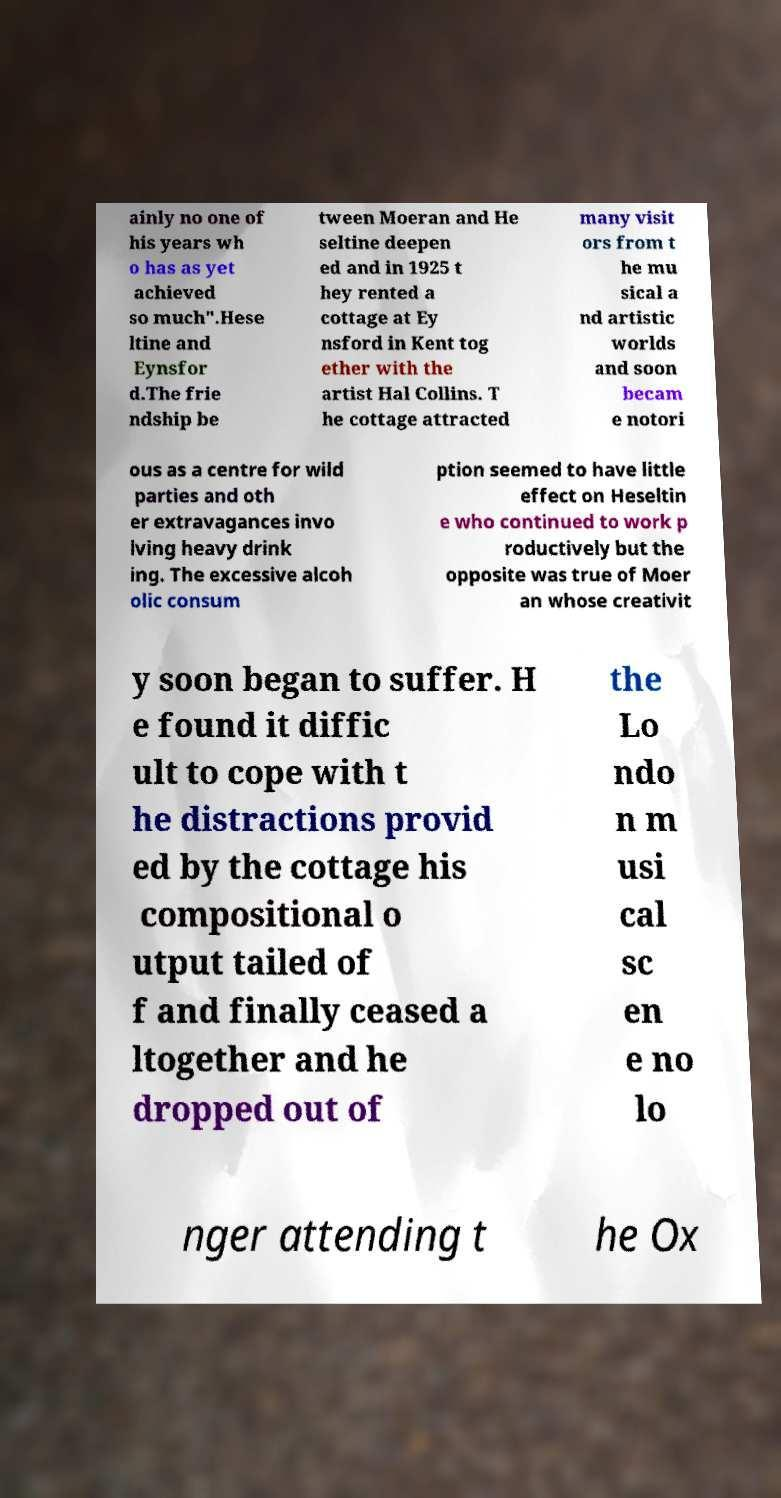Can you read and provide the text displayed in the image?This photo seems to have some interesting text. Can you extract and type it out for me? ainly no one of his years wh o has as yet achieved so much".Hese ltine and Eynsfor d.The frie ndship be tween Moeran and He seltine deepen ed and in 1925 t hey rented a cottage at Ey nsford in Kent tog ether with the artist Hal Collins. T he cottage attracted many visit ors from t he mu sical a nd artistic worlds and soon becam e notori ous as a centre for wild parties and oth er extravagances invo lving heavy drink ing. The excessive alcoh olic consum ption seemed to have little effect on Heseltin e who continued to work p roductively but the opposite was true of Moer an whose creativit y soon began to suffer. H e found it diffic ult to cope with t he distractions provid ed by the cottage his compositional o utput tailed of f and finally ceased a ltogether and he dropped out of the Lo ndo n m usi cal sc en e no lo nger attending t he Ox 